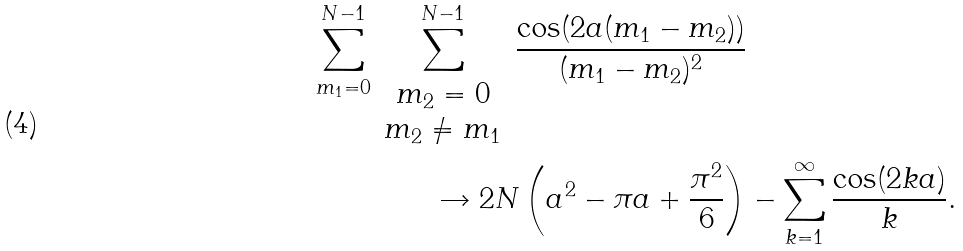Convert formula to latex. <formula><loc_0><loc_0><loc_500><loc_500>\sum _ { m _ { 1 } = 0 } ^ { N - 1 } \sum _ { \begin{array} { c } m _ { 2 } = 0 \\ m _ { 2 } \neq m _ { 1 } \end{array} } ^ { N - 1 } \frac { \cos ( 2 a ( m _ { 1 } - m _ { 2 } ) ) } { ( m _ { 1 } - m _ { 2 } ) ^ { 2 } } & \\ \rightarrow 2 N \left ( a ^ { 2 } - \pi a + \frac { \pi ^ { 2 } } { 6 } \right ) & - \sum _ { k = 1 } ^ { \infty } \frac { \cos ( 2 k a ) } { k } .</formula> 